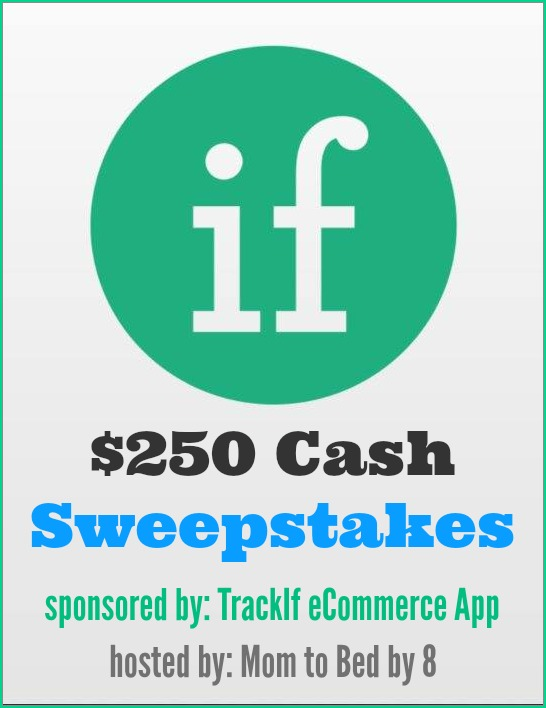What could be a possible scenario of a participant winning the $250 Cash Sweepstakes? Imagine a busy mom, Emma, who follows the 'Mom to Bed by 8' blog for its useful parenting tips and product reviews. One evening, she stumbles upon the $250 Cash Sweepstakes sponsored by TrackIf eCommerce App. Intrigued by the potential to win extra cash for her family, she decides to enter the sweepstakes by following the simple instructions on the website. She learns about TrackIf eCommerce App in the process and finds it useful for tracking the prices of products she plans to buy for her kids. A few weeks later, Emma receives an email announcing that she is the winner of the sweepstakes! Overjoyed, she uses the $250 cash prize to purchase a much-needed baby stroller and proudly shares her win and the usefulness of the TrackIf app on her social media, drawing more attention to both 'Mom to Bed by 8' and TrackIf eCommerce App. 